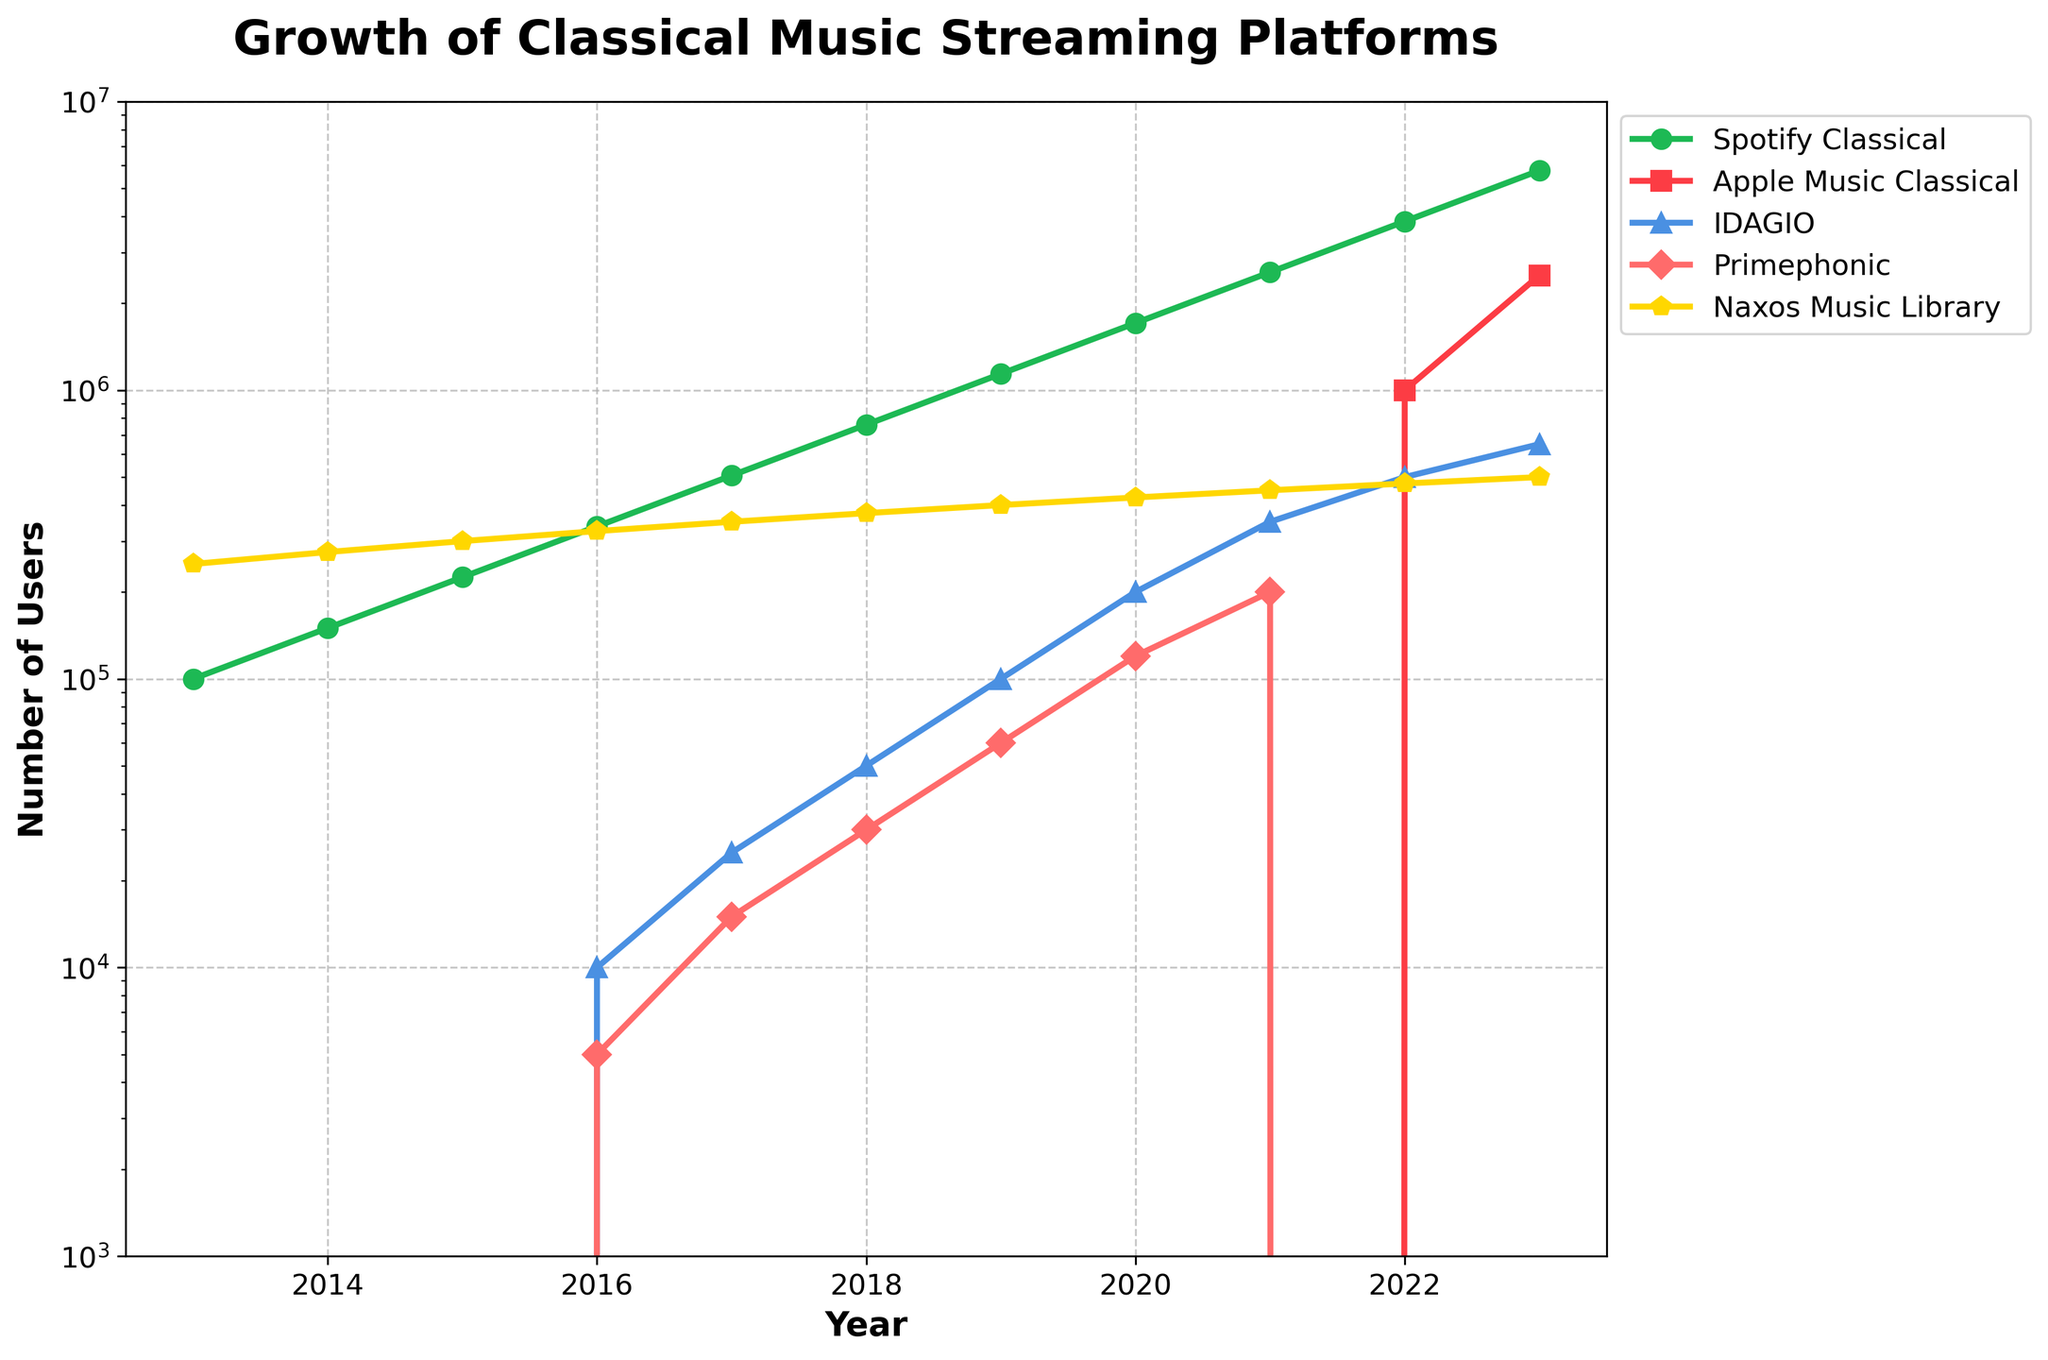What year did Apple Music Classical first appear on the chart? Apple Music Classical first appears in 2022 on the chart with 1,000,000 users.
Answer: 2022 Which platform had the highest number of users in 2023? The chart shows that in 2023, Spotify Classical had the highest number of users with 5,766,504.
Answer: Spotify Classical What’s the difference in the user base between IDAGIO and Primephonic in 2020? In 2020, IDAGIO had 200,000 users and Primephonic had 120,000 users. The difference is 200,000 - 120,000 = 80,000.
Answer: 80,000 How did the user numbers for Naxos Music Library change from 2013 to 2018? Naxos Music Library had 250,000 users in 2013 and 375,000 in 2018. The change is 375,000 - 250,000 = 125,000.
Answer: 125,000 Between which consecutive years did Spotify Classical see its largest increase in user numbers? Checking the differences year by year for Spotify Classical, the largest increase was from 2022 to 2023, with an increase of 5,766,504 - 3,844,336 = 1,922,168.
Answer: 2022 to 2023 What year did Primephonic drop out of the chart? Primephonic has data points until 2021, and there is no data for 2022 and 2023. Therefore, Primephonic dropped out in 2022.
Answer: 2022 Which years had new platforms appear on the chart? In 2016, IDAGIO and Primephonic appeared on the chart. Apple Music Classical appeared in 2022.
Answer: 2016 and 2022 Which platform had the most consistent growth over the decade? By observing the trends, Naxos Music Library shows a steady growth pattern compared to others with rapid increases or drops.
Answer: Naxos Music Library What was the combined user base of IDAGIO and Primephonic in 2018? In 2018, IDAGIO had 50,000 users and Primephonic had 30,000. The combined user base is 50,000 + 30,000 = 80,000.
Answer: 80,000 How long after Spotify Classical did Apple Music Classical first appear on the chart? Spotify Classical first appeared in 2013 and Apple Music Classical in 2022. The difference is 2022 - 2013 = 9 years.
Answer: 9 years 